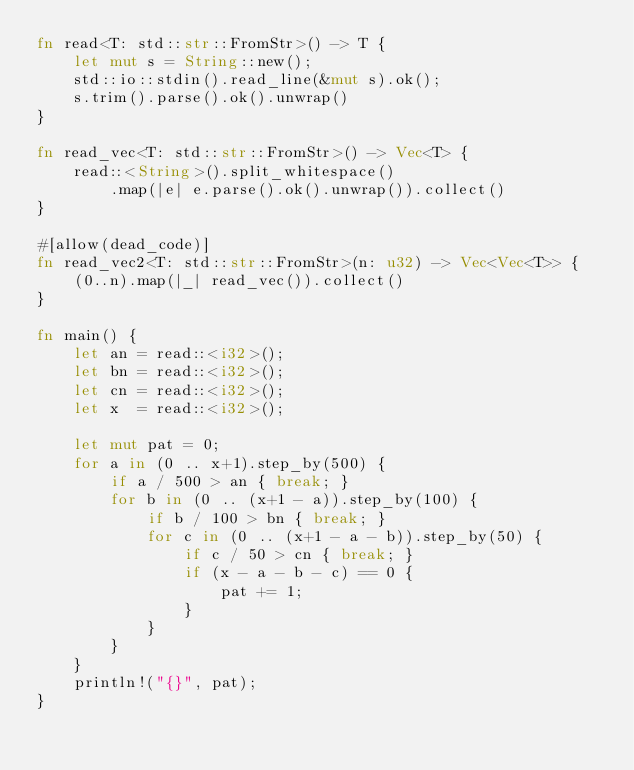<code> <loc_0><loc_0><loc_500><loc_500><_Rust_>fn read<T: std::str::FromStr>() -> T {
    let mut s = String::new();
    std::io::stdin().read_line(&mut s).ok();
    s.trim().parse().ok().unwrap()
}

fn read_vec<T: std::str::FromStr>() -> Vec<T> {
    read::<String>().split_whitespace()
        .map(|e| e.parse().ok().unwrap()).collect()
}

#[allow(dead_code)]
fn read_vec2<T: std::str::FromStr>(n: u32) -> Vec<Vec<T>> {
    (0..n).map(|_| read_vec()).collect()
}

fn main() {
    let an = read::<i32>();
    let bn = read::<i32>();
    let cn = read::<i32>();
    let x  = read::<i32>();

    let mut pat = 0;
    for a in (0 .. x+1).step_by(500) {
        if a / 500 > an { break; }
        for b in (0 .. (x+1 - a)).step_by(100) {
            if b / 100 > bn { break; }
            for c in (0 .. (x+1 - a - b)).step_by(50) {
                if c / 50 > cn { break; }
                if (x - a - b - c) == 0 {
                    pat += 1;
                }
            }
        }
    }
    println!("{}", pat);
}
</code> 